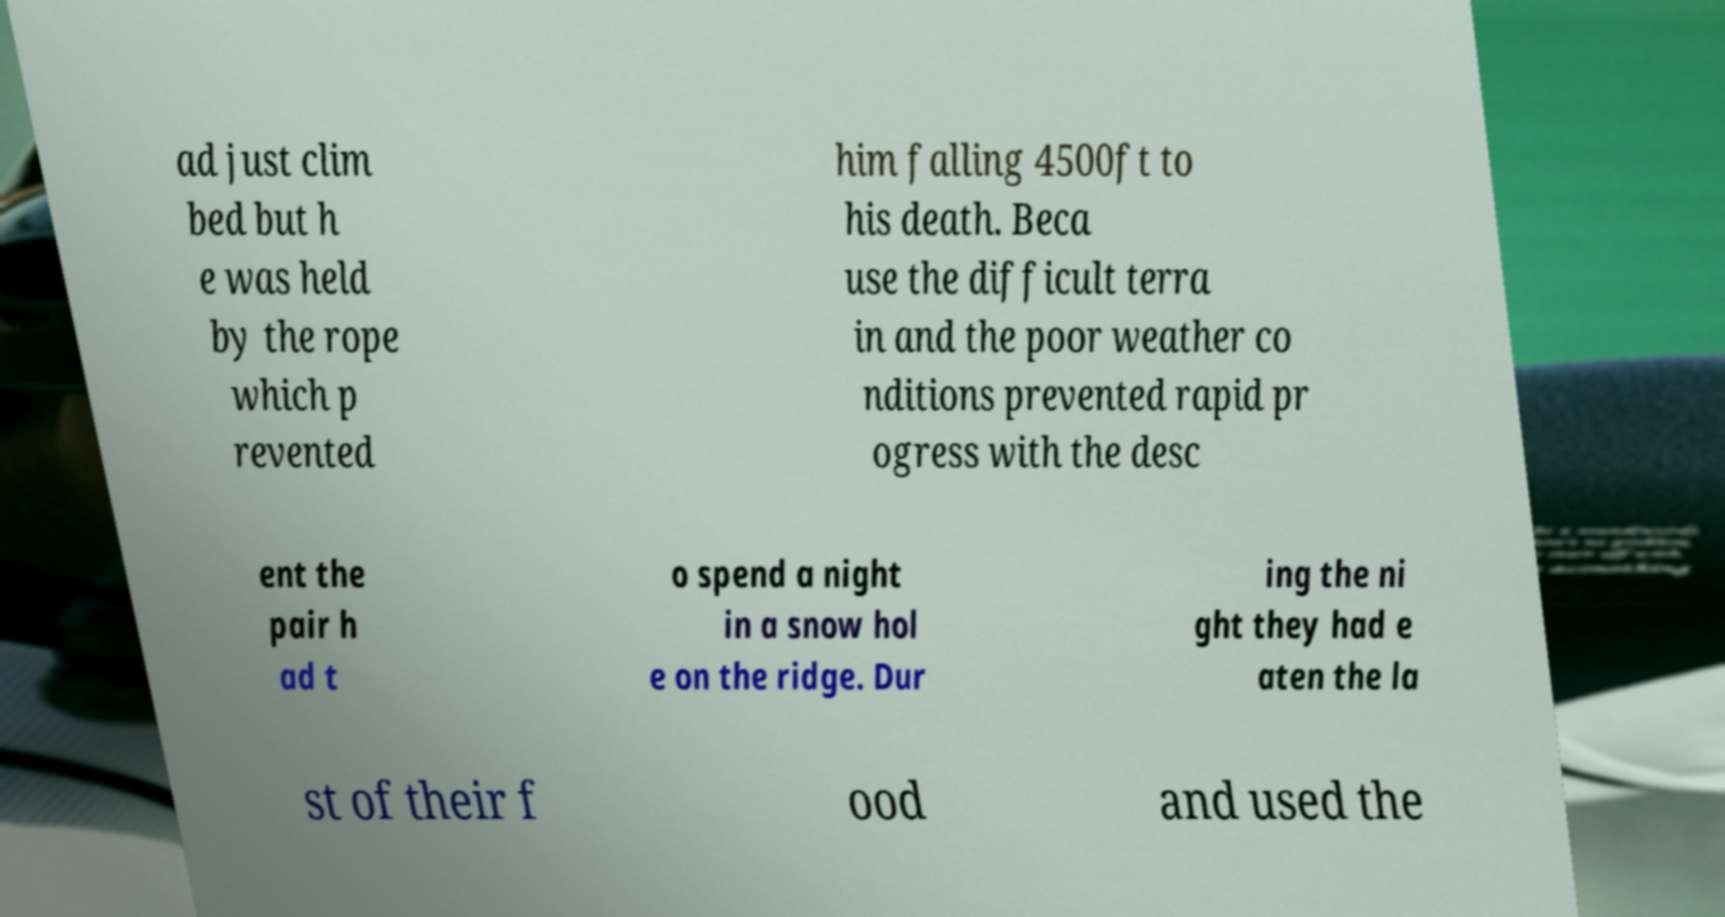For documentation purposes, I need the text within this image transcribed. Could you provide that? ad just clim bed but h e was held by the rope which p revented him falling 4500ft to his death. Beca use the difficult terra in and the poor weather co nditions prevented rapid pr ogress with the desc ent the pair h ad t o spend a night in a snow hol e on the ridge. Dur ing the ni ght they had e aten the la st of their f ood and used the 